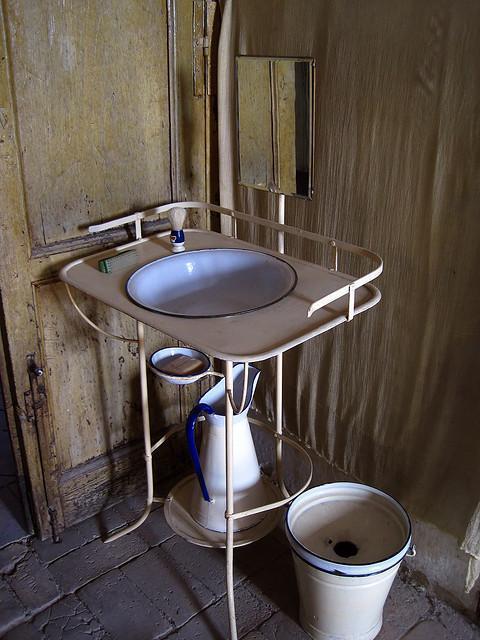How many blue lanterns are hanging on the left side of the banana bunches?
Give a very brief answer. 0. 